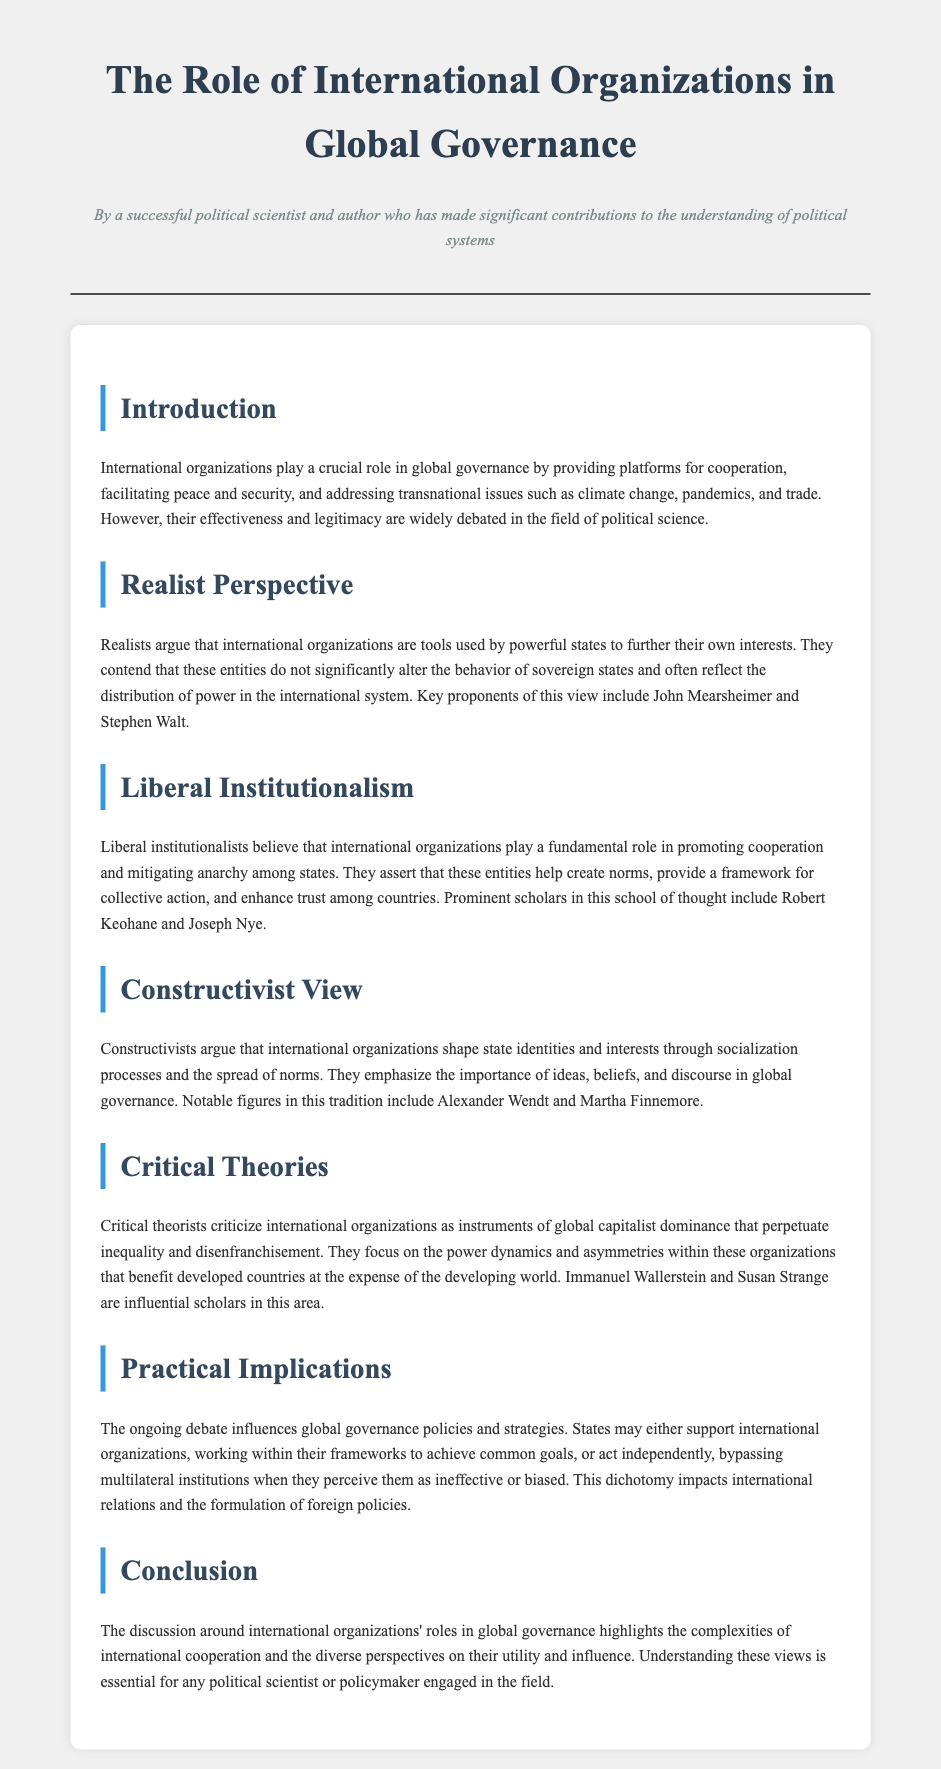What is the title of the document? The title is prominently displayed at the top of the document, indicating the focus of the content.
Answer: The Role of International Organizations in Global Governance Who is identified as a proponent of the realist perspective? The document lists John Mearsheimer and Stephen Walt as key proponents of the realist perspective on international organizations.
Answer: John Mearsheimer and Stephen Walt What school of thought emphasizes the role of ideas and norms? The constructivist view is highlighted in the document as emphasizing the significance of ideas, beliefs, and discourse.
Answer: Constructivist View Which scholar is associated with Liberal Institutionalism? The document indicates Robert Keohane as a prominent scholar in the Liberal Institutionalism school of thought.
Answer: Robert Keohane What critical concern do critical theorists raise about international organizations? The document mentions that critical theorists critique international organizations as instruments of global capitalist dominance.
Answer: Instruments of global capitalist dominance How do practical implications vary in relation to international organizations? The document explains that states may either support international organizations or act independently, depending on their perceptions.
Answer: Support or act independently Who are two influential scholars in critical theories? The document specifies Immanuel Wallerstein and Susan Strange as influential scholars in the field of critical theories.
Answer: Immanuel Wallerstein and Susan Strange What issue do international organizations address according to the introduction? The introduction mentions addressing transnational issues such as climate change.
Answer: Climate change What does the liberal institutionalism perspective assert? The document states that liberal institutionalists assert that international organizations promote cooperation and mitigate anarchy.
Answer: Promote cooperation and mitigate anarchy 